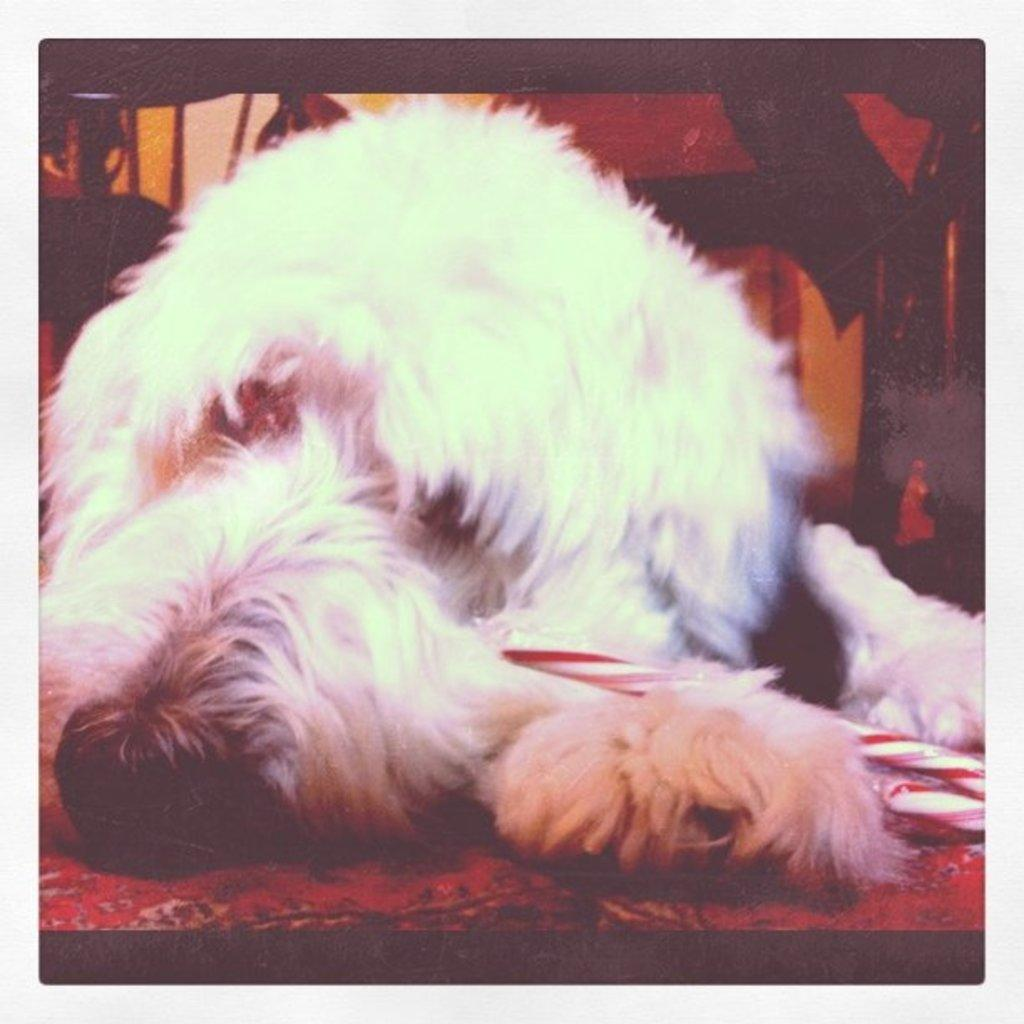What animal can be seen in the image? There is a dog in the image. What is the dog doing in the image? The dog is lying on a mat. Can you describe the object on the right side of the image? Unfortunately, the facts provided do not give any information about the object on the right side of the image. What type of gate is present in the image? There is no gate present in the image. What does the dog's representative say about the situation in the image? The concept of a dog's representative does not apply in this context, as the image is a static representation and does not involve any communication or negotiation. 